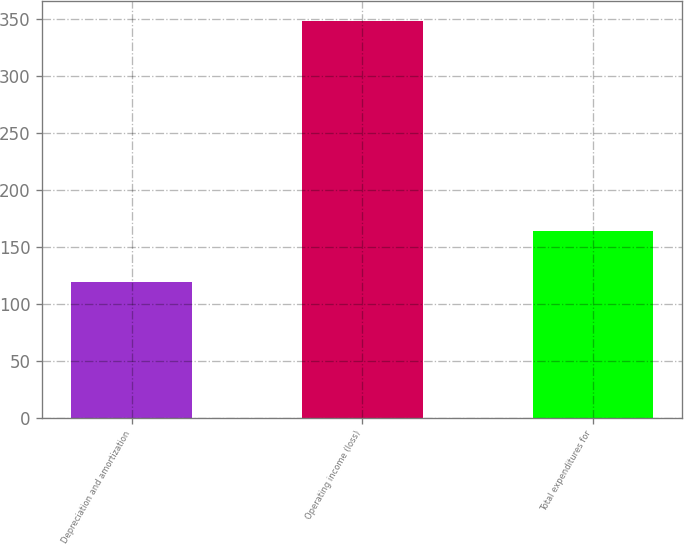Convert chart. <chart><loc_0><loc_0><loc_500><loc_500><bar_chart><fcel>Depreciation and amortization<fcel>Operating income (loss)<fcel>Total expenditures for<nl><fcel>119<fcel>348<fcel>164<nl></chart> 